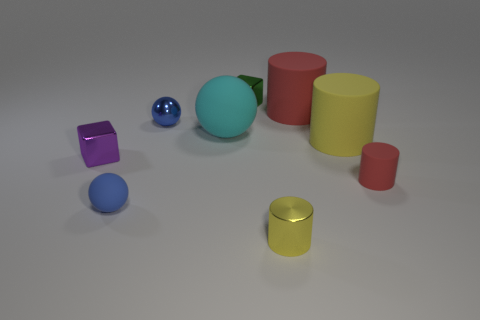There is a green object that is the same shape as the tiny purple shiny object; what is it made of?
Ensure brevity in your answer.  Metal. There is another metallic thing that is the same shape as the cyan object; what is its color?
Offer a very short reply. Blue. What is the material of the big red thing?
Your answer should be compact. Rubber. Are there more purple shiny things than red metal things?
Your answer should be compact. Yes. Do the big yellow rubber thing and the small green shiny object have the same shape?
Your response must be concise. No. Is there anything else that has the same shape as the small red thing?
Offer a very short reply. Yes. Do the small rubber thing that is on the left side of the large yellow cylinder and the block behind the big yellow rubber cylinder have the same color?
Your answer should be very brief. No. Is the number of metal cylinders behind the tiny rubber sphere less than the number of big rubber spheres that are behind the big red object?
Make the answer very short. No. What shape is the small blue object behind the big yellow cylinder?
Offer a terse response. Sphere. What is the material of the large object that is the same color as the shiny cylinder?
Your response must be concise. Rubber. 